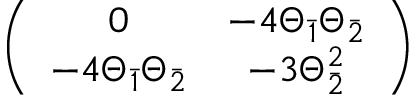Convert formula to latex. <formula><loc_0><loc_0><loc_500><loc_500>\left ( \begin{array} { c c } { 0 } & { { - 4 \Theta _ { \bar { 1 } } \Theta _ { \bar { 2 } } } } \\ { { - 4 \Theta _ { \bar { 1 } } \Theta _ { \bar { 2 } } } } & { { - 3 \Theta _ { \bar { 2 } } ^ { 2 } } } \end{array} \right )</formula> 